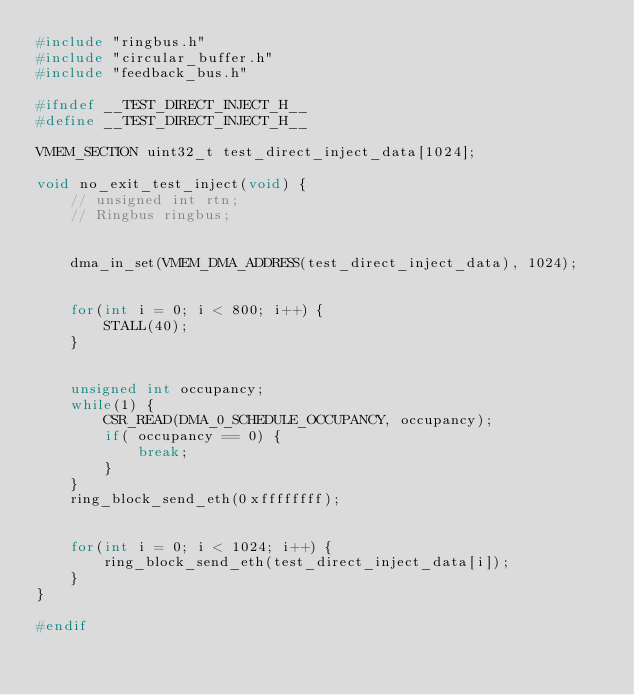Convert code to text. <code><loc_0><loc_0><loc_500><loc_500><_C_>#include "ringbus.h"
#include "circular_buffer.h"
#include "feedback_bus.h"

#ifndef __TEST_DIRECT_INJECT_H__
#define __TEST_DIRECT_INJECT_H__

VMEM_SECTION uint32_t test_direct_inject_data[1024];

void no_exit_test_inject(void) {
    // unsigned int rtn;
    // Ringbus ringbus;


    dma_in_set(VMEM_DMA_ADDRESS(test_direct_inject_data), 1024);


    for(int i = 0; i < 800; i++) {
        STALL(40);
    }


    unsigned int occupancy;
    while(1) {
        CSR_READ(DMA_0_SCHEDULE_OCCUPANCY, occupancy);
        if( occupancy == 0) {
            break;
        }
    }
    ring_block_send_eth(0xffffffff);


    for(int i = 0; i < 1024; i++) {
        ring_block_send_eth(test_direct_inject_data[i]);
    }
}

#endif</code> 